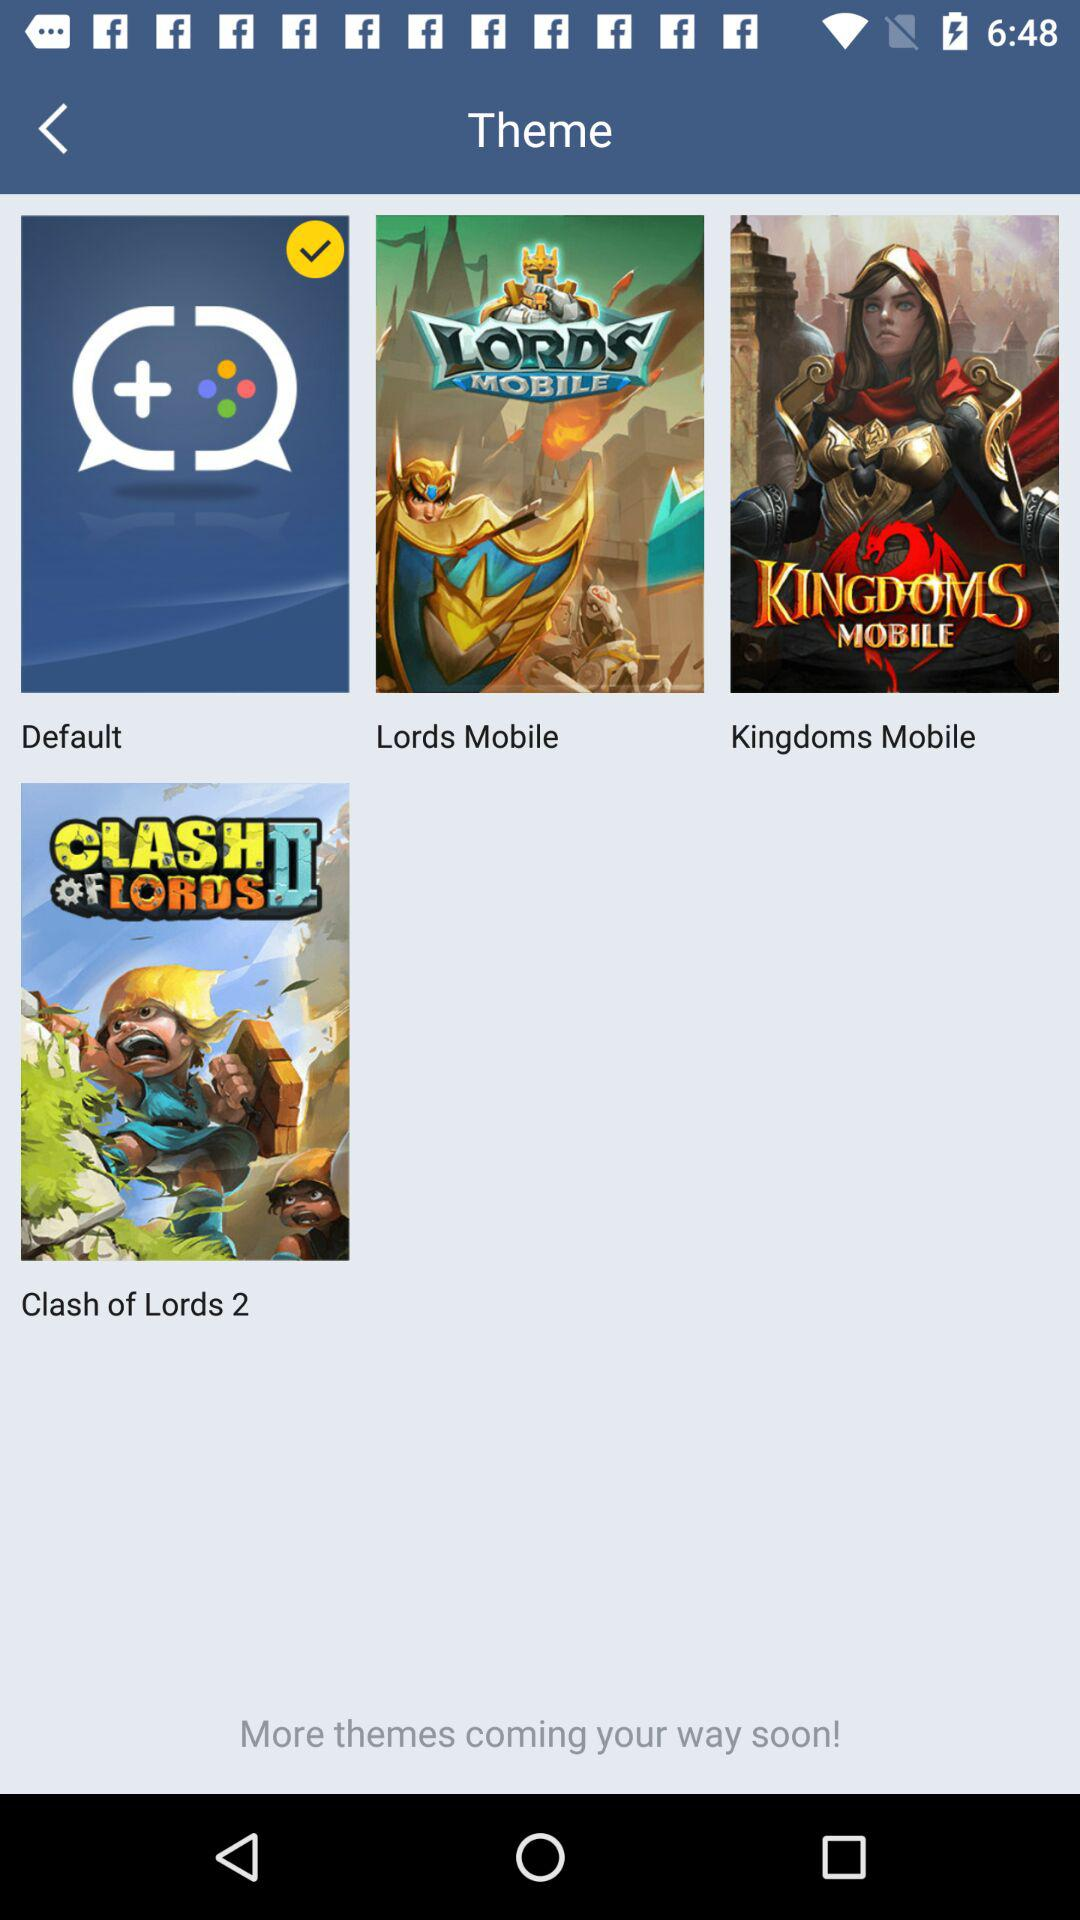Which option has been selected? The selected option is "Default". 